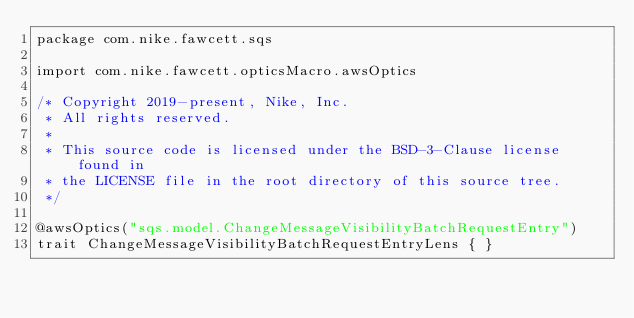Convert code to text. <code><loc_0><loc_0><loc_500><loc_500><_Scala_>package com.nike.fawcett.sqs

import com.nike.fawcett.opticsMacro.awsOptics

/* Copyright 2019-present, Nike, Inc.
 * All rights reserved.
 *
 * This source code is licensed under the BSD-3-Clause license found in
 * the LICENSE file in the root directory of this source tree.
 */

@awsOptics("sqs.model.ChangeMessageVisibilityBatchRequestEntry")
trait ChangeMessageVisibilityBatchRequestEntryLens { }
</code> 